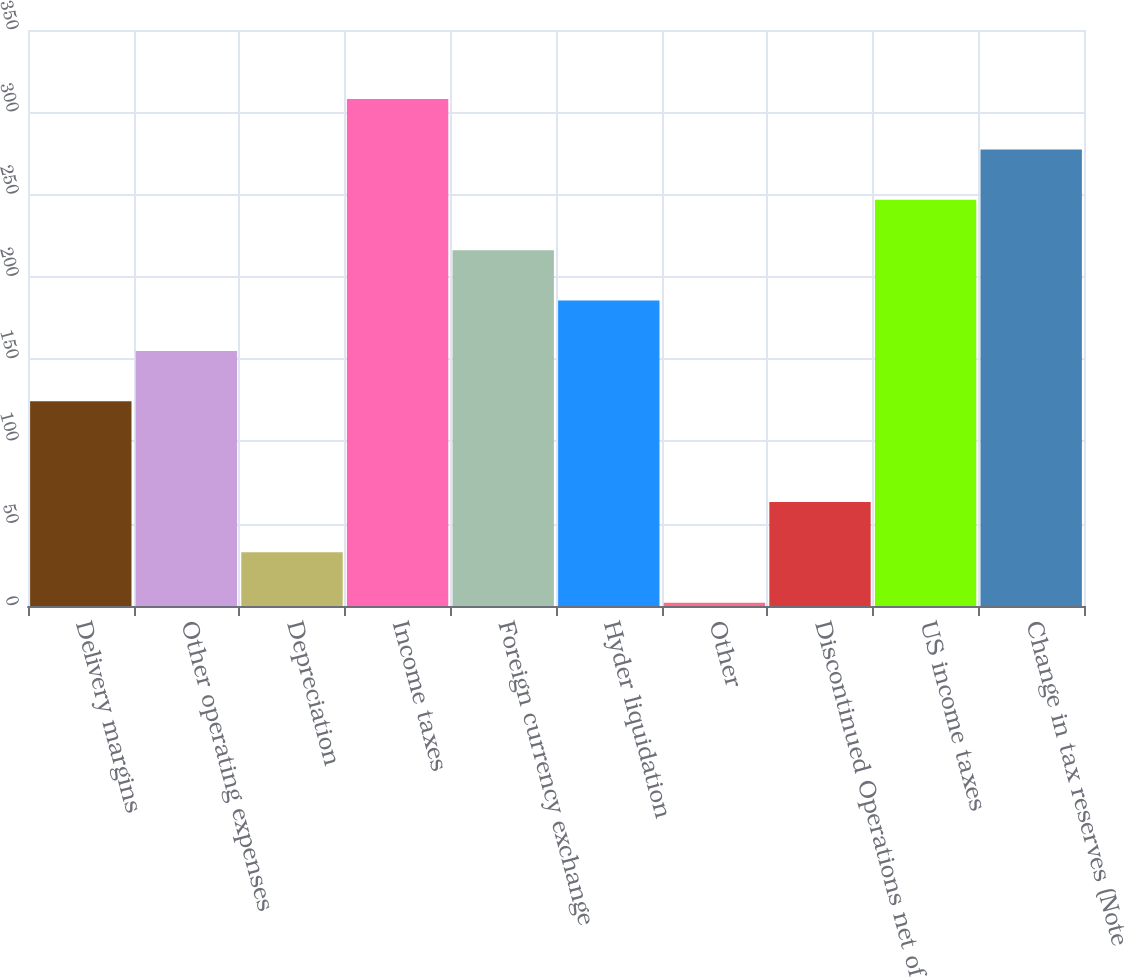Convert chart. <chart><loc_0><loc_0><loc_500><loc_500><bar_chart><fcel>Delivery margins<fcel>Other operating expenses<fcel>Depreciation<fcel>Income taxes<fcel>Foreign currency exchange<fcel>Hyder liquidation<fcel>Other<fcel>Discontinued Operations net of<fcel>US income taxes<fcel>Change in tax reserves (Note<nl><fcel>124.4<fcel>155<fcel>32.6<fcel>308<fcel>216.2<fcel>185.6<fcel>2<fcel>63.2<fcel>246.8<fcel>277.4<nl></chart> 